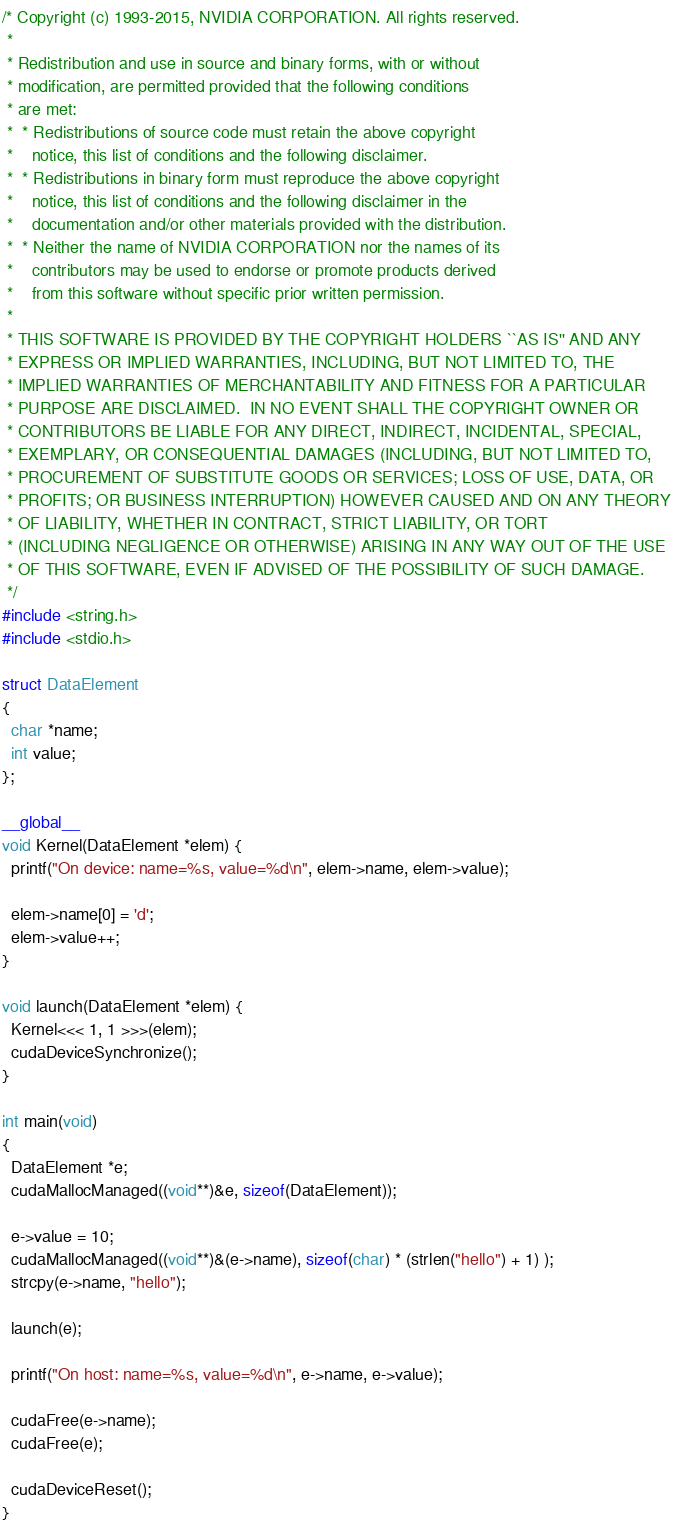<code> <loc_0><loc_0><loc_500><loc_500><_Cuda_>/* Copyright (c) 1993-2015, NVIDIA CORPORATION. All rights reserved.
 *
 * Redistribution and use in source and binary forms, with or without
 * modification, are permitted provided that the following conditions
 * are met:
 *  * Redistributions of source code must retain the above copyright
 *    notice, this list of conditions and the following disclaimer.
 *  * Redistributions in binary form must reproduce the above copyright
 *    notice, this list of conditions and the following disclaimer in the
 *    documentation and/or other materials provided with the distribution.
 *  * Neither the name of NVIDIA CORPORATION nor the names of its
 *    contributors may be used to endorse or promote products derived
 *    from this software without specific prior written permission.
 *
 * THIS SOFTWARE IS PROVIDED BY THE COPYRIGHT HOLDERS ``AS IS'' AND ANY
 * EXPRESS OR IMPLIED WARRANTIES, INCLUDING, BUT NOT LIMITED TO, THE
 * IMPLIED WARRANTIES OF MERCHANTABILITY AND FITNESS FOR A PARTICULAR
 * PURPOSE ARE DISCLAIMED.  IN NO EVENT SHALL THE COPYRIGHT OWNER OR
 * CONTRIBUTORS BE LIABLE FOR ANY DIRECT, INDIRECT, INCIDENTAL, SPECIAL,
 * EXEMPLARY, OR CONSEQUENTIAL DAMAGES (INCLUDING, BUT NOT LIMITED TO,
 * PROCUREMENT OF SUBSTITUTE GOODS OR SERVICES; LOSS OF USE, DATA, OR
 * PROFITS; OR BUSINESS INTERRUPTION) HOWEVER CAUSED AND ON ANY THEORY
 * OF LIABILITY, WHETHER IN CONTRACT, STRICT LIABILITY, OR TORT
 * (INCLUDING NEGLIGENCE OR OTHERWISE) ARISING IN ANY WAY OUT OF THE USE
 * OF THIS SOFTWARE, EVEN IF ADVISED OF THE POSSIBILITY OF SUCH DAMAGE.
 */
#include <string.h>
#include <stdio.h>

struct DataElement
{
  char *name;
  int value;
};

__global__ 
void Kernel(DataElement *elem) {
  printf("On device: name=%s, value=%d\n", elem->name, elem->value);

  elem->name[0] = 'd';
  elem->value++;
}

void launch(DataElement *elem) {
  Kernel<<< 1, 1 >>>(elem);
  cudaDeviceSynchronize();
}

int main(void)
{
  DataElement *e;
  cudaMallocManaged((void**)&e, sizeof(DataElement));

  e->value = 10;
  cudaMallocManaged((void**)&(e->name), sizeof(char) * (strlen("hello") + 1) );
  strcpy(e->name, "hello");

  launch(e);

  printf("On host: name=%s, value=%d\n", e->name, e->value);

  cudaFree(e->name);
  cudaFree(e);

  cudaDeviceReset();
}</code> 